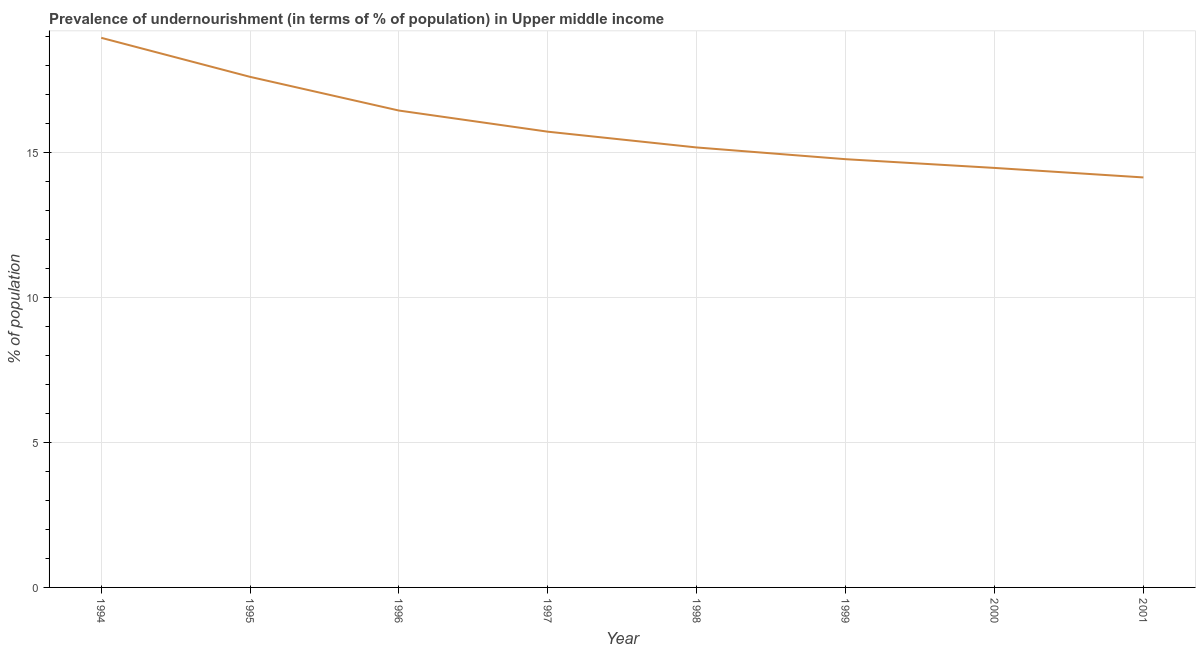What is the percentage of undernourished population in 2001?
Offer a terse response. 14.14. Across all years, what is the maximum percentage of undernourished population?
Your answer should be very brief. 18.95. Across all years, what is the minimum percentage of undernourished population?
Ensure brevity in your answer.  14.14. What is the sum of the percentage of undernourished population?
Offer a very short reply. 127.24. What is the difference between the percentage of undernourished population in 1994 and 1996?
Ensure brevity in your answer.  2.51. What is the average percentage of undernourished population per year?
Make the answer very short. 15.91. What is the median percentage of undernourished population?
Offer a terse response. 15.44. In how many years, is the percentage of undernourished population greater than 5 %?
Make the answer very short. 8. Do a majority of the years between 1995 and 1996 (inclusive) have percentage of undernourished population greater than 15 %?
Offer a very short reply. Yes. What is the ratio of the percentage of undernourished population in 1995 to that in 2000?
Your answer should be very brief. 1.22. Is the difference between the percentage of undernourished population in 1995 and 1997 greater than the difference between any two years?
Offer a very short reply. No. What is the difference between the highest and the second highest percentage of undernourished population?
Provide a short and direct response. 1.35. What is the difference between the highest and the lowest percentage of undernourished population?
Provide a succinct answer. 4.81. In how many years, is the percentage of undernourished population greater than the average percentage of undernourished population taken over all years?
Ensure brevity in your answer.  3. How many years are there in the graph?
Your answer should be very brief. 8. Are the values on the major ticks of Y-axis written in scientific E-notation?
Make the answer very short. No. Does the graph contain any zero values?
Your response must be concise. No. What is the title of the graph?
Offer a terse response. Prevalence of undernourishment (in terms of % of population) in Upper middle income. What is the label or title of the X-axis?
Keep it short and to the point. Year. What is the label or title of the Y-axis?
Offer a terse response. % of population. What is the % of population of 1994?
Your answer should be compact. 18.95. What is the % of population in 1995?
Provide a short and direct response. 17.6. What is the % of population of 1996?
Provide a short and direct response. 16.44. What is the % of population in 1997?
Offer a very short reply. 15.71. What is the % of population in 1998?
Your answer should be compact. 15.17. What is the % of population in 1999?
Your answer should be compact. 14.77. What is the % of population of 2000?
Offer a very short reply. 14.46. What is the % of population in 2001?
Give a very brief answer. 14.14. What is the difference between the % of population in 1994 and 1995?
Make the answer very short. 1.35. What is the difference between the % of population in 1994 and 1996?
Provide a succinct answer. 2.51. What is the difference between the % of population in 1994 and 1997?
Keep it short and to the point. 3.24. What is the difference between the % of population in 1994 and 1998?
Provide a succinct answer. 3.78. What is the difference between the % of population in 1994 and 1999?
Ensure brevity in your answer.  4.19. What is the difference between the % of population in 1994 and 2000?
Keep it short and to the point. 4.49. What is the difference between the % of population in 1994 and 2001?
Provide a short and direct response. 4.81. What is the difference between the % of population in 1995 and 1996?
Provide a succinct answer. 1.16. What is the difference between the % of population in 1995 and 1997?
Ensure brevity in your answer.  1.89. What is the difference between the % of population in 1995 and 1998?
Provide a succinct answer. 2.43. What is the difference between the % of population in 1995 and 1999?
Offer a very short reply. 2.84. What is the difference between the % of population in 1995 and 2000?
Offer a very short reply. 3.14. What is the difference between the % of population in 1995 and 2001?
Your answer should be very brief. 3.47. What is the difference between the % of population in 1996 and 1997?
Give a very brief answer. 0.73. What is the difference between the % of population in 1996 and 1998?
Provide a short and direct response. 1.27. What is the difference between the % of population in 1996 and 1999?
Your answer should be compact. 1.68. What is the difference between the % of population in 1996 and 2000?
Keep it short and to the point. 1.98. What is the difference between the % of population in 1996 and 2001?
Make the answer very short. 2.31. What is the difference between the % of population in 1997 and 1998?
Your response must be concise. 0.54. What is the difference between the % of population in 1997 and 1999?
Make the answer very short. 0.95. What is the difference between the % of population in 1997 and 2000?
Give a very brief answer. 1.25. What is the difference between the % of population in 1997 and 2001?
Ensure brevity in your answer.  1.58. What is the difference between the % of population in 1998 and 1999?
Ensure brevity in your answer.  0.4. What is the difference between the % of population in 1998 and 2000?
Provide a succinct answer. 0.71. What is the difference between the % of population in 1998 and 2001?
Your answer should be very brief. 1.03. What is the difference between the % of population in 1999 and 2000?
Your answer should be compact. 0.3. What is the difference between the % of population in 1999 and 2001?
Make the answer very short. 0.63. What is the difference between the % of population in 2000 and 2001?
Make the answer very short. 0.33. What is the ratio of the % of population in 1994 to that in 1995?
Your response must be concise. 1.08. What is the ratio of the % of population in 1994 to that in 1996?
Provide a succinct answer. 1.15. What is the ratio of the % of population in 1994 to that in 1997?
Make the answer very short. 1.21. What is the ratio of the % of population in 1994 to that in 1998?
Provide a short and direct response. 1.25. What is the ratio of the % of population in 1994 to that in 1999?
Ensure brevity in your answer.  1.28. What is the ratio of the % of population in 1994 to that in 2000?
Make the answer very short. 1.31. What is the ratio of the % of population in 1994 to that in 2001?
Your response must be concise. 1.34. What is the ratio of the % of population in 1995 to that in 1996?
Your answer should be very brief. 1.07. What is the ratio of the % of population in 1995 to that in 1997?
Make the answer very short. 1.12. What is the ratio of the % of population in 1995 to that in 1998?
Give a very brief answer. 1.16. What is the ratio of the % of population in 1995 to that in 1999?
Your response must be concise. 1.19. What is the ratio of the % of population in 1995 to that in 2000?
Your response must be concise. 1.22. What is the ratio of the % of population in 1995 to that in 2001?
Provide a succinct answer. 1.25. What is the ratio of the % of population in 1996 to that in 1997?
Give a very brief answer. 1.05. What is the ratio of the % of population in 1996 to that in 1998?
Your answer should be very brief. 1.08. What is the ratio of the % of population in 1996 to that in 1999?
Provide a succinct answer. 1.11. What is the ratio of the % of population in 1996 to that in 2000?
Keep it short and to the point. 1.14. What is the ratio of the % of population in 1996 to that in 2001?
Offer a very short reply. 1.16. What is the ratio of the % of population in 1997 to that in 1998?
Keep it short and to the point. 1.04. What is the ratio of the % of population in 1997 to that in 1999?
Your answer should be very brief. 1.06. What is the ratio of the % of population in 1997 to that in 2000?
Offer a terse response. 1.09. What is the ratio of the % of population in 1997 to that in 2001?
Provide a succinct answer. 1.11. What is the ratio of the % of population in 1998 to that in 2000?
Give a very brief answer. 1.05. What is the ratio of the % of population in 1998 to that in 2001?
Ensure brevity in your answer.  1.07. What is the ratio of the % of population in 1999 to that in 2000?
Your response must be concise. 1.02. What is the ratio of the % of population in 1999 to that in 2001?
Make the answer very short. 1.04. What is the ratio of the % of population in 2000 to that in 2001?
Offer a terse response. 1.02. 